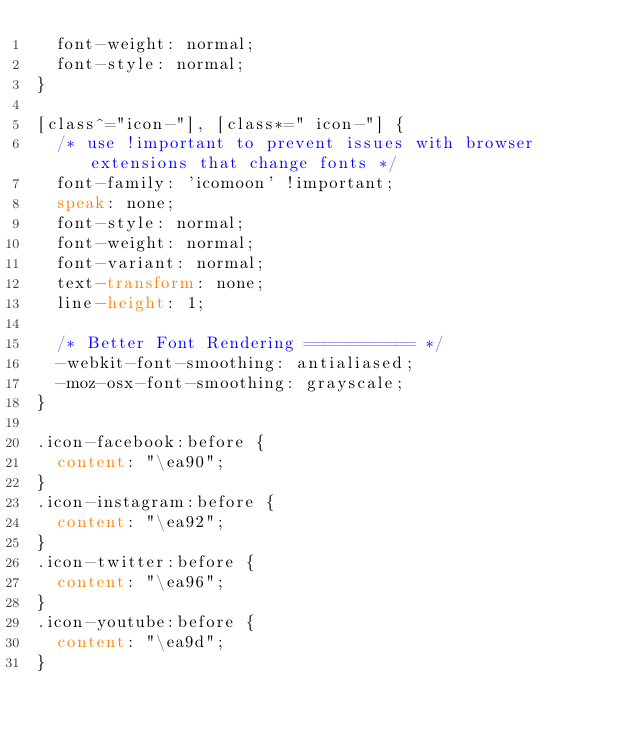<code> <loc_0><loc_0><loc_500><loc_500><_CSS_>  font-weight: normal;
  font-style: normal;
}

[class^="icon-"], [class*=" icon-"] {
  /* use !important to prevent issues with browser extensions that change fonts */
  font-family: 'icomoon' !important;
  speak: none;
  font-style: normal;
  font-weight: normal;
  font-variant: normal;
  text-transform: none;
  line-height: 1;

  /* Better Font Rendering =========== */
  -webkit-font-smoothing: antialiased;
  -moz-osx-font-smoothing: grayscale;
}

.icon-facebook:before {
  content: "\ea90";
}
.icon-instagram:before {
  content: "\ea92";
}
.icon-twitter:before {
  content: "\ea96";
}
.icon-youtube:before {
  content: "\ea9d";
}
</code> 